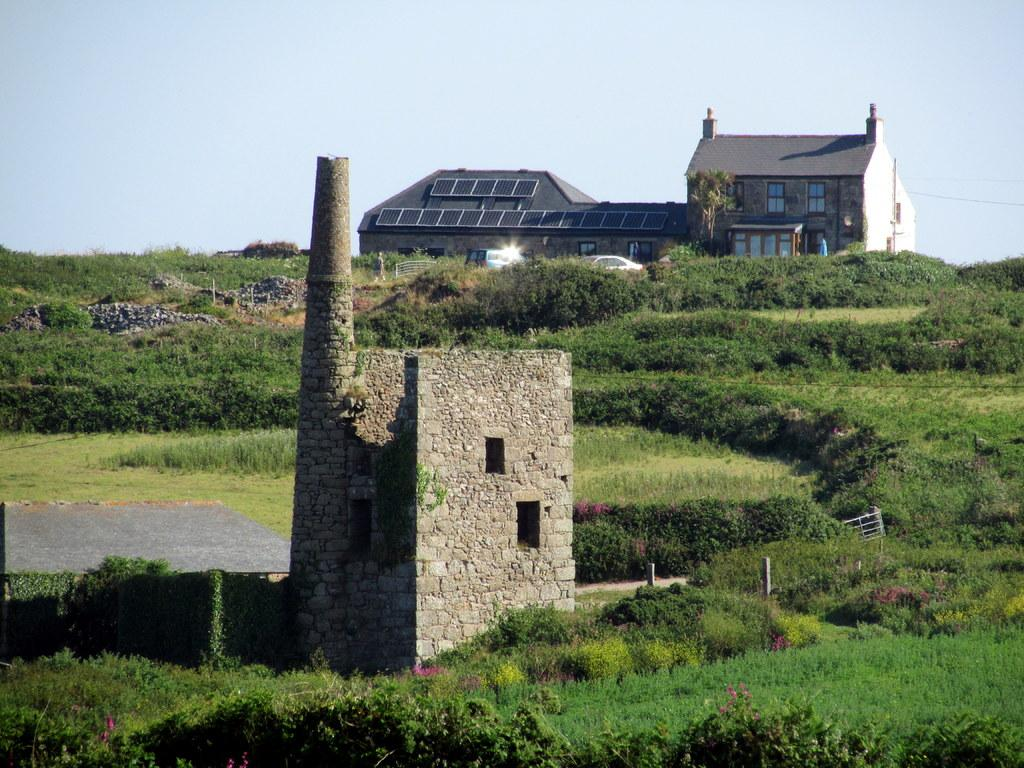What type of natural environment is visible in the image? There is grass and plants in the image, indicating a natural environment. What man-made structures can be seen in the image? There is a house and vehicles visible in the image. What is visible in the background of the image? The sky is visible in the background of the image. How thick is the fog in the image? There is no fog present in the image; the sky is visible in the background. 